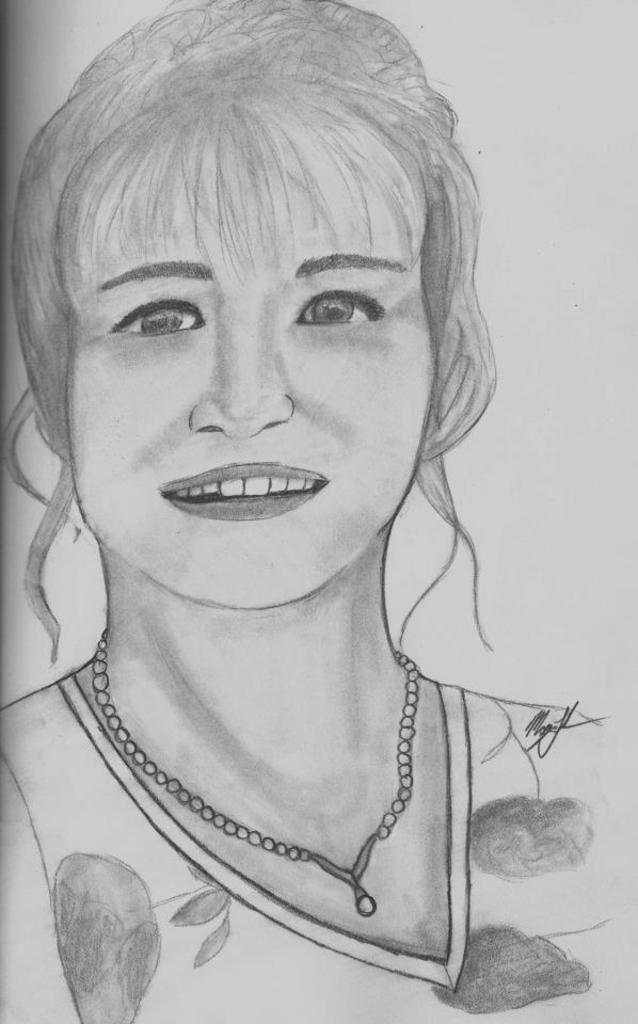Please provide a concise description of this image. This is the picture of a drawing of a lady and she has a chain around the neck. 